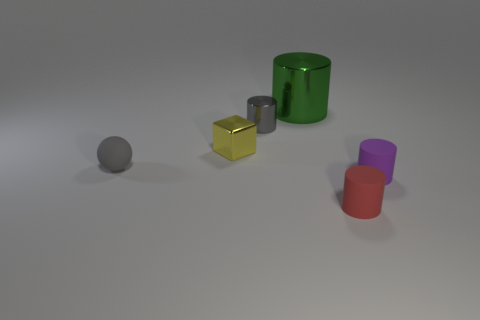Subtract all tiny gray cylinders. How many cylinders are left? 3 Subtract all purple cylinders. How many blue cubes are left? 0 Add 2 large red metallic objects. How many objects exist? 8 Subtract all red cylinders. How many cylinders are left? 3 Subtract 1 gray balls. How many objects are left? 5 Subtract all cylinders. How many objects are left? 2 Subtract all green cylinders. Subtract all green spheres. How many cylinders are left? 3 Subtract all green metal things. Subtract all large purple matte cylinders. How many objects are left? 5 Add 3 big green metal objects. How many big green metal objects are left? 4 Add 6 gray objects. How many gray objects exist? 8 